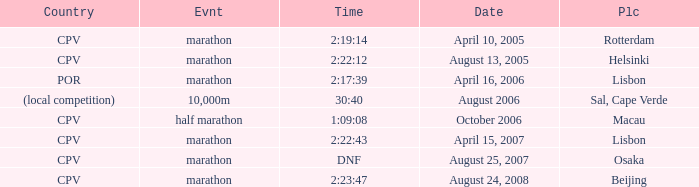What is the Country of the 10,000m Event? (local competition). 